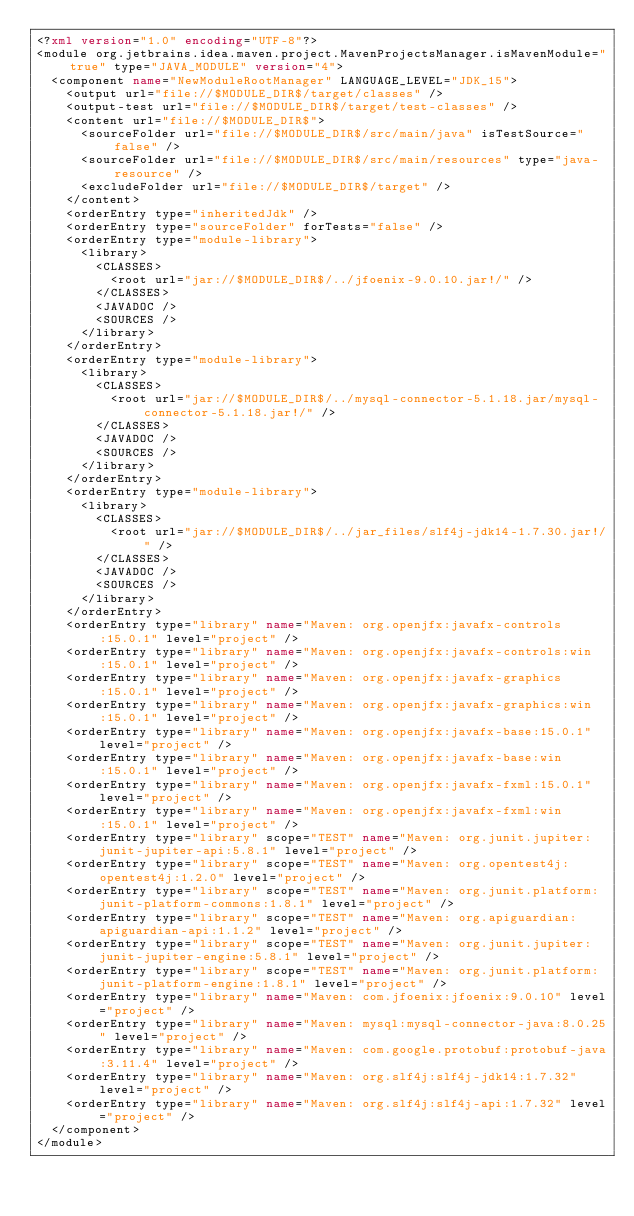Convert code to text. <code><loc_0><loc_0><loc_500><loc_500><_XML_><?xml version="1.0" encoding="UTF-8"?>
<module org.jetbrains.idea.maven.project.MavenProjectsManager.isMavenModule="true" type="JAVA_MODULE" version="4">
  <component name="NewModuleRootManager" LANGUAGE_LEVEL="JDK_15">
    <output url="file://$MODULE_DIR$/target/classes" />
    <output-test url="file://$MODULE_DIR$/target/test-classes" />
    <content url="file://$MODULE_DIR$">
      <sourceFolder url="file://$MODULE_DIR$/src/main/java" isTestSource="false" />
      <sourceFolder url="file://$MODULE_DIR$/src/main/resources" type="java-resource" />
      <excludeFolder url="file://$MODULE_DIR$/target" />
    </content>
    <orderEntry type="inheritedJdk" />
    <orderEntry type="sourceFolder" forTests="false" />
    <orderEntry type="module-library">
      <library>
        <CLASSES>
          <root url="jar://$MODULE_DIR$/../jfoenix-9.0.10.jar!/" />
        </CLASSES>
        <JAVADOC />
        <SOURCES />
      </library>
    </orderEntry>
    <orderEntry type="module-library">
      <library>
        <CLASSES>
          <root url="jar://$MODULE_DIR$/../mysql-connector-5.1.18.jar/mysql-connector-5.1.18.jar!/" />
        </CLASSES>
        <JAVADOC />
        <SOURCES />
      </library>
    </orderEntry>
    <orderEntry type="module-library">
      <library>
        <CLASSES>
          <root url="jar://$MODULE_DIR$/../jar_files/slf4j-jdk14-1.7.30.jar!/" />
        </CLASSES>
        <JAVADOC />
        <SOURCES />
      </library>
    </orderEntry>
    <orderEntry type="library" name="Maven: org.openjfx:javafx-controls:15.0.1" level="project" />
    <orderEntry type="library" name="Maven: org.openjfx:javafx-controls:win:15.0.1" level="project" />
    <orderEntry type="library" name="Maven: org.openjfx:javafx-graphics:15.0.1" level="project" />
    <orderEntry type="library" name="Maven: org.openjfx:javafx-graphics:win:15.0.1" level="project" />
    <orderEntry type="library" name="Maven: org.openjfx:javafx-base:15.0.1" level="project" />
    <orderEntry type="library" name="Maven: org.openjfx:javafx-base:win:15.0.1" level="project" />
    <orderEntry type="library" name="Maven: org.openjfx:javafx-fxml:15.0.1" level="project" />
    <orderEntry type="library" name="Maven: org.openjfx:javafx-fxml:win:15.0.1" level="project" />
    <orderEntry type="library" scope="TEST" name="Maven: org.junit.jupiter:junit-jupiter-api:5.8.1" level="project" />
    <orderEntry type="library" scope="TEST" name="Maven: org.opentest4j:opentest4j:1.2.0" level="project" />
    <orderEntry type="library" scope="TEST" name="Maven: org.junit.platform:junit-platform-commons:1.8.1" level="project" />
    <orderEntry type="library" scope="TEST" name="Maven: org.apiguardian:apiguardian-api:1.1.2" level="project" />
    <orderEntry type="library" scope="TEST" name="Maven: org.junit.jupiter:junit-jupiter-engine:5.8.1" level="project" />
    <orderEntry type="library" scope="TEST" name="Maven: org.junit.platform:junit-platform-engine:1.8.1" level="project" />
    <orderEntry type="library" name="Maven: com.jfoenix:jfoenix:9.0.10" level="project" />
    <orderEntry type="library" name="Maven: mysql:mysql-connector-java:8.0.25" level="project" />
    <orderEntry type="library" name="Maven: com.google.protobuf:protobuf-java:3.11.4" level="project" />
    <orderEntry type="library" name="Maven: org.slf4j:slf4j-jdk14:1.7.32" level="project" />
    <orderEntry type="library" name="Maven: org.slf4j:slf4j-api:1.7.32" level="project" />
  </component>
</module></code> 